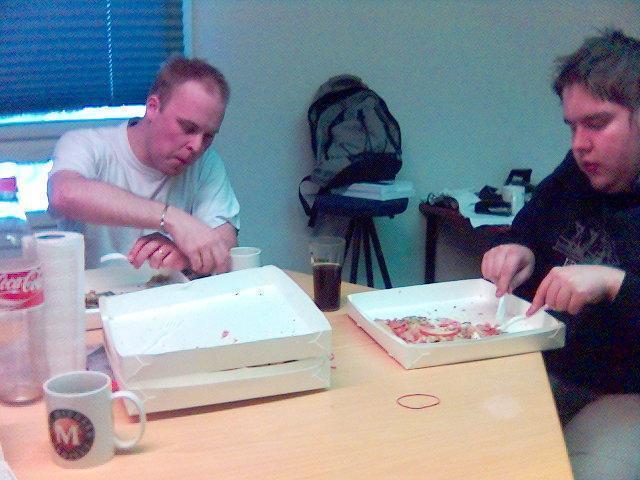What type of beverages are being consumed by the pizza eater?
Select the accurate response from the four choices given to answer the question.
Options: Beer, wine, milkshakes, soft drinks. Soft drinks. 